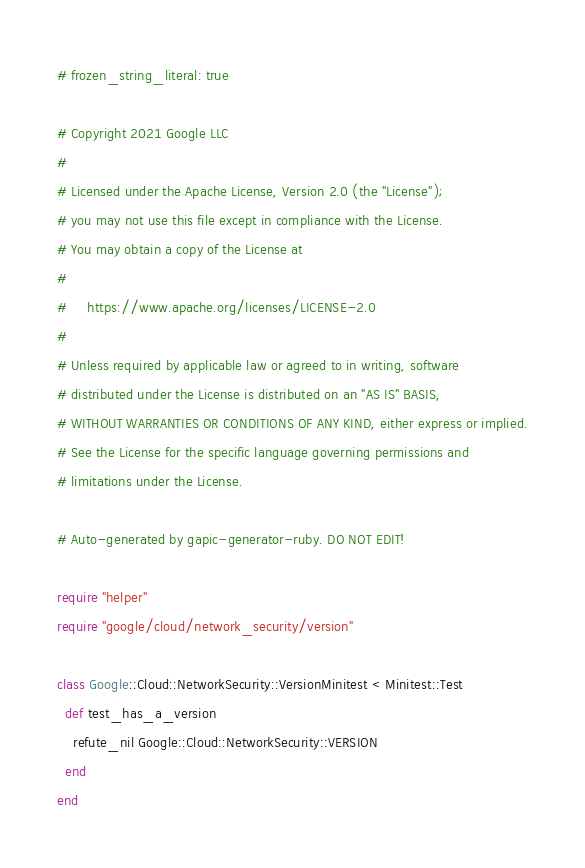Convert code to text. <code><loc_0><loc_0><loc_500><loc_500><_Ruby_># frozen_string_literal: true

# Copyright 2021 Google LLC
#
# Licensed under the Apache License, Version 2.0 (the "License");
# you may not use this file except in compliance with the License.
# You may obtain a copy of the License at
#
#     https://www.apache.org/licenses/LICENSE-2.0
#
# Unless required by applicable law or agreed to in writing, software
# distributed under the License is distributed on an "AS IS" BASIS,
# WITHOUT WARRANTIES OR CONDITIONS OF ANY KIND, either express or implied.
# See the License for the specific language governing permissions and
# limitations under the License.

# Auto-generated by gapic-generator-ruby. DO NOT EDIT!

require "helper"
require "google/cloud/network_security/version"

class Google::Cloud::NetworkSecurity::VersionMinitest < Minitest::Test
  def test_has_a_version
    refute_nil Google::Cloud::NetworkSecurity::VERSION
  end
end
</code> 